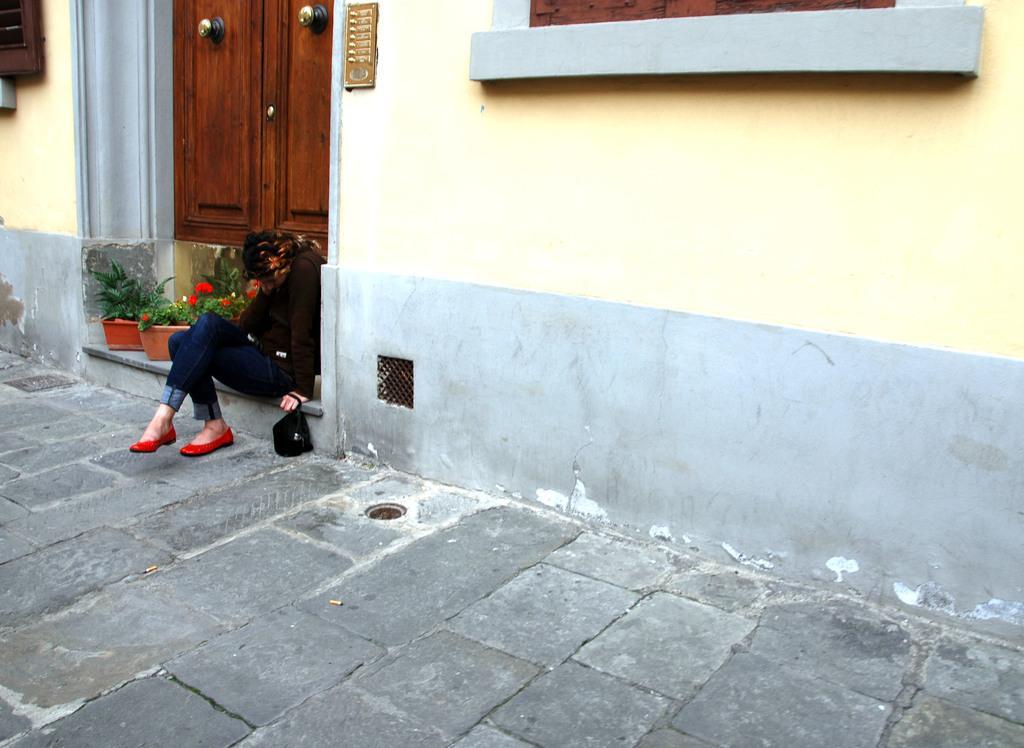How would you summarize this image in a sentence or two? In this image a woman is sitting on the floor having few pots. Pots are having plants in it. She is holding a bag in her hand. Background there is a wall having a window. 